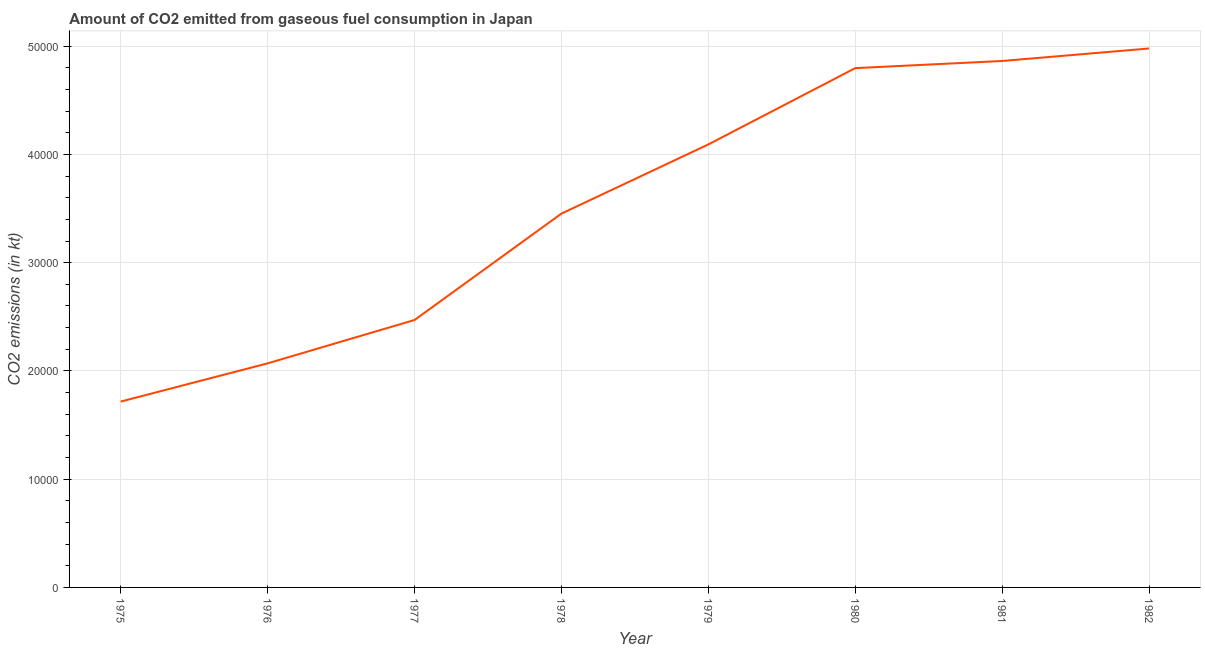What is the co2 emissions from gaseous fuel consumption in 1978?
Your answer should be very brief. 3.45e+04. Across all years, what is the maximum co2 emissions from gaseous fuel consumption?
Ensure brevity in your answer.  4.98e+04. Across all years, what is the minimum co2 emissions from gaseous fuel consumption?
Ensure brevity in your answer.  1.72e+04. In which year was the co2 emissions from gaseous fuel consumption maximum?
Give a very brief answer. 1982. In which year was the co2 emissions from gaseous fuel consumption minimum?
Provide a succinct answer. 1975. What is the sum of the co2 emissions from gaseous fuel consumption?
Keep it short and to the point. 2.84e+05. What is the difference between the co2 emissions from gaseous fuel consumption in 1975 and 1977?
Give a very brief answer. -7535.69. What is the average co2 emissions from gaseous fuel consumption per year?
Offer a terse response. 3.56e+04. What is the median co2 emissions from gaseous fuel consumption?
Offer a terse response. 3.77e+04. In how many years, is the co2 emissions from gaseous fuel consumption greater than 34000 kt?
Make the answer very short. 5. What is the ratio of the co2 emissions from gaseous fuel consumption in 1979 to that in 1980?
Keep it short and to the point. 0.85. Is the co2 emissions from gaseous fuel consumption in 1977 less than that in 1982?
Ensure brevity in your answer.  Yes. What is the difference between the highest and the second highest co2 emissions from gaseous fuel consumption?
Provide a short and direct response. 1155.1. Is the sum of the co2 emissions from gaseous fuel consumption in 1980 and 1982 greater than the maximum co2 emissions from gaseous fuel consumption across all years?
Make the answer very short. Yes. What is the difference between the highest and the lowest co2 emissions from gaseous fuel consumption?
Keep it short and to the point. 3.26e+04. In how many years, is the co2 emissions from gaseous fuel consumption greater than the average co2 emissions from gaseous fuel consumption taken over all years?
Keep it short and to the point. 4. How many lines are there?
Ensure brevity in your answer.  1. How many years are there in the graph?
Provide a short and direct response. 8. Does the graph contain any zero values?
Keep it short and to the point. No. Does the graph contain grids?
Ensure brevity in your answer.  Yes. What is the title of the graph?
Make the answer very short. Amount of CO2 emitted from gaseous fuel consumption in Japan. What is the label or title of the X-axis?
Provide a succinct answer. Year. What is the label or title of the Y-axis?
Ensure brevity in your answer.  CO2 emissions (in kt). What is the CO2 emissions (in kt) in 1975?
Provide a succinct answer. 1.72e+04. What is the CO2 emissions (in kt) in 1976?
Your response must be concise. 2.07e+04. What is the CO2 emissions (in kt) in 1977?
Ensure brevity in your answer.  2.47e+04. What is the CO2 emissions (in kt) of 1978?
Give a very brief answer. 3.45e+04. What is the CO2 emissions (in kt) in 1979?
Make the answer very short. 4.09e+04. What is the CO2 emissions (in kt) in 1980?
Offer a very short reply. 4.80e+04. What is the CO2 emissions (in kt) of 1981?
Give a very brief answer. 4.86e+04. What is the CO2 emissions (in kt) in 1982?
Ensure brevity in your answer.  4.98e+04. What is the difference between the CO2 emissions (in kt) in 1975 and 1976?
Your response must be concise. -3531.32. What is the difference between the CO2 emissions (in kt) in 1975 and 1977?
Your response must be concise. -7535.69. What is the difference between the CO2 emissions (in kt) in 1975 and 1978?
Offer a terse response. -1.74e+04. What is the difference between the CO2 emissions (in kt) in 1975 and 1979?
Your response must be concise. -2.38e+04. What is the difference between the CO2 emissions (in kt) in 1975 and 1980?
Offer a very short reply. -3.08e+04. What is the difference between the CO2 emissions (in kt) in 1975 and 1981?
Offer a very short reply. -3.15e+04. What is the difference between the CO2 emissions (in kt) in 1975 and 1982?
Provide a succinct answer. -3.26e+04. What is the difference between the CO2 emissions (in kt) in 1976 and 1977?
Your answer should be very brief. -4004.36. What is the difference between the CO2 emissions (in kt) in 1976 and 1978?
Your answer should be very brief. -1.38e+04. What is the difference between the CO2 emissions (in kt) in 1976 and 1979?
Ensure brevity in your answer.  -2.02e+04. What is the difference between the CO2 emissions (in kt) in 1976 and 1980?
Offer a terse response. -2.73e+04. What is the difference between the CO2 emissions (in kt) in 1976 and 1981?
Offer a very short reply. -2.79e+04. What is the difference between the CO2 emissions (in kt) in 1976 and 1982?
Offer a terse response. -2.91e+04. What is the difference between the CO2 emissions (in kt) in 1977 and 1978?
Your response must be concise. -9827.56. What is the difference between the CO2 emissions (in kt) in 1977 and 1979?
Make the answer very short. -1.62e+04. What is the difference between the CO2 emissions (in kt) in 1977 and 1980?
Your answer should be very brief. -2.33e+04. What is the difference between the CO2 emissions (in kt) in 1977 and 1981?
Make the answer very short. -2.39e+04. What is the difference between the CO2 emissions (in kt) in 1977 and 1982?
Give a very brief answer. -2.51e+04. What is the difference between the CO2 emissions (in kt) in 1978 and 1979?
Your answer should be compact. -6391.58. What is the difference between the CO2 emissions (in kt) in 1978 and 1980?
Your response must be concise. -1.34e+04. What is the difference between the CO2 emissions (in kt) in 1978 and 1981?
Keep it short and to the point. -1.41e+04. What is the difference between the CO2 emissions (in kt) in 1978 and 1982?
Keep it short and to the point. -1.53e+04. What is the difference between the CO2 emissions (in kt) in 1979 and 1980?
Your answer should be very brief. -7047.97. What is the difference between the CO2 emissions (in kt) in 1979 and 1981?
Provide a short and direct response. -7708.03. What is the difference between the CO2 emissions (in kt) in 1979 and 1982?
Your answer should be compact. -8863.14. What is the difference between the CO2 emissions (in kt) in 1980 and 1981?
Offer a very short reply. -660.06. What is the difference between the CO2 emissions (in kt) in 1980 and 1982?
Provide a succinct answer. -1815.16. What is the difference between the CO2 emissions (in kt) in 1981 and 1982?
Your answer should be compact. -1155.11. What is the ratio of the CO2 emissions (in kt) in 1975 to that in 1976?
Offer a terse response. 0.83. What is the ratio of the CO2 emissions (in kt) in 1975 to that in 1977?
Offer a terse response. 0.69. What is the ratio of the CO2 emissions (in kt) in 1975 to that in 1978?
Provide a succinct answer. 0.5. What is the ratio of the CO2 emissions (in kt) in 1975 to that in 1979?
Keep it short and to the point. 0.42. What is the ratio of the CO2 emissions (in kt) in 1975 to that in 1980?
Ensure brevity in your answer.  0.36. What is the ratio of the CO2 emissions (in kt) in 1975 to that in 1981?
Provide a short and direct response. 0.35. What is the ratio of the CO2 emissions (in kt) in 1975 to that in 1982?
Your response must be concise. 0.34. What is the ratio of the CO2 emissions (in kt) in 1976 to that in 1977?
Give a very brief answer. 0.84. What is the ratio of the CO2 emissions (in kt) in 1976 to that in 1978?
Ensure brevity in your answer.  0.6. What is the ratio of the CO2 emissions (in kt) in 1976 to that in 1979?
Ensure brevity in your answer.  0.51. What is the ratio of the CO2 emissions (in kt) in 1976 to that in 1980?
Your answer should be very brief. 0.43. What is the ratio of the CO2 emissions (in kt) in 1976 to that in 1981?
Your answer should be compact. 0.43. What is the ratio of the CO2 emissions (in kt) in 1976 to that in 1982?
Your answer should be compact. 0.42. What is the ratio of the CO2 emissions (in kt) in 1977 to that in 1978?
Your answer should be compact. 0.71. What is the ratio of the CO2 emissions (in kt) in 1977 to that in 1979?
Keep it short and to the point. 0.6. What is the ratio of the CO2 emissions (in kt) in 1977 to that in 1980?
Your answer should be compact. 0.52. What is the ratio of the CO2 emissions (in kt) in 1977 to that in 1981?
Provide a short and direct response. 0.51. What is the ratio of the CO2 emissions (in kt) in 1977 to that in 1982?
Make the answer very short. 0.5. What is the ratio of the CO2 emissions (in kt) in 1978 to that in 1979?
Your response must be concise. 0.84. What is the ratio of the CO2 emissions (in kt) in 1978 to that in 1980?
Your answer should be very brief. 0.72. What is the ratio of the CO2 emissions (in kt) in 1978 to that in 1981?
Your answer should be compact. 0.71. What is the ratio of the CO2 emissions (in kt) in 1978 to that in 1982?
Keep it short and to the point. 0.69. What is the ratio of the CO2 emissions (in kt) in 1979 to that in 1980?
Provide a short and direct response. 0.85. What is the ratio of the CO2 emissions (in kt) in 1979 to that in 1981?
Provide a short and direct response. 0.84. What is the ratio of the CO2 emissions (in kt) in 1979 to that in 1982?
Offer a very short reply. 0.82. What is the ratio of the CO2 emissions (in kt) in 1981 to that in 1982?
Make the answer very short. 0.98. 